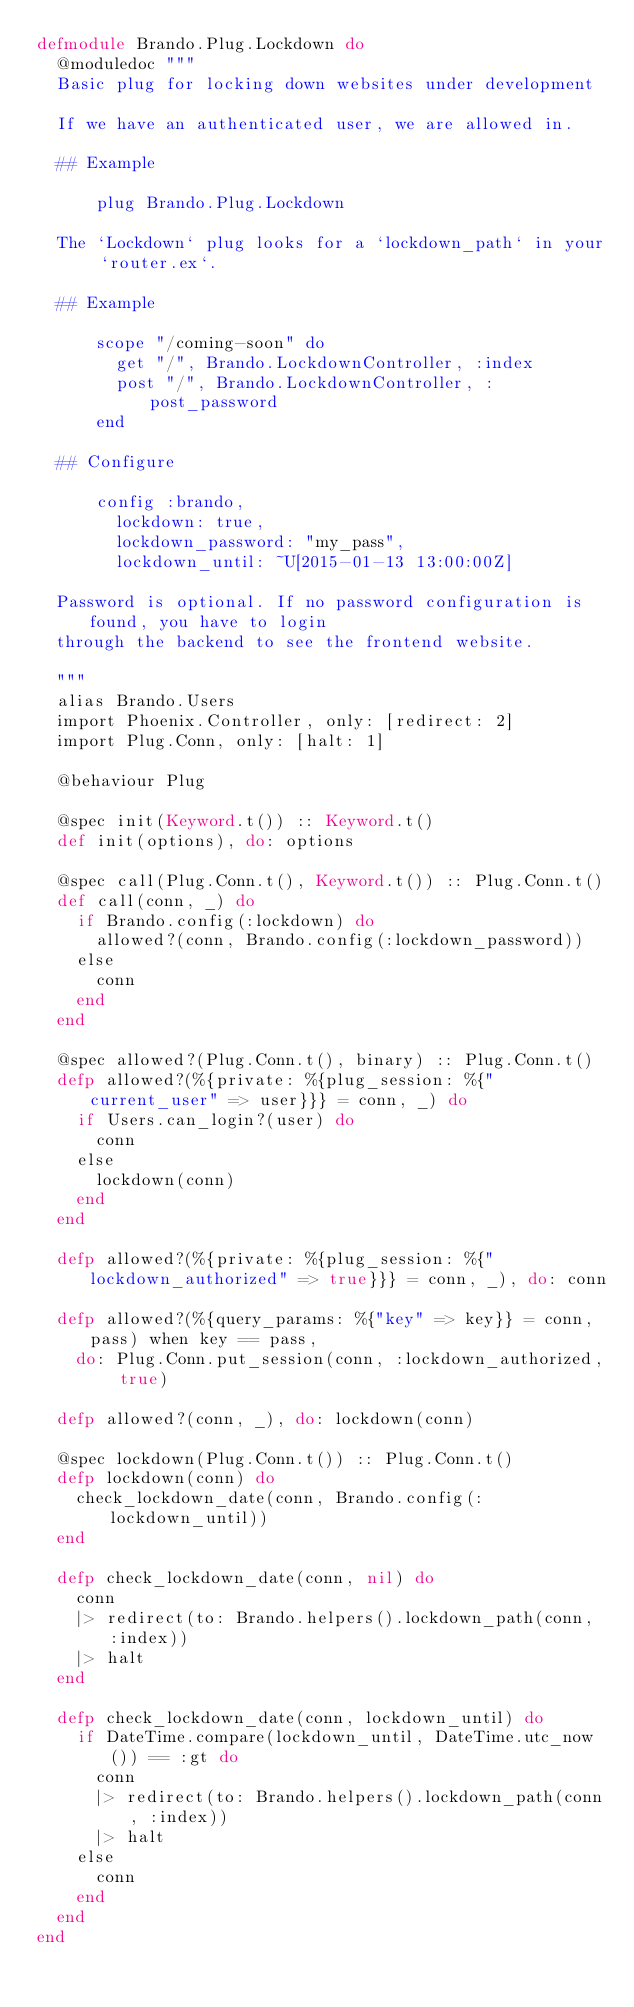<code> <loc_0><loc_0><loc_500><loc_500><_Elixir_>defmodule Brando.Plug.Lockdown do
  @moduledoc """
  Basic plug for locking down websites under development

  If we have an authenticated user, we are allowed in.

  ## Example

      plug Brando.Plug.Lockdown

  The `Lockdown` plug looks for a `lockdown_path` in your `router.ex`.

  ## Example

      scope "/coming-soon" do
        get "/", Brando.LockdownController, :index
        post "/", Brando.LockdownController, :post_password
      end

  ## Configure

      config :brando,
        lockdown: true,
        lockdown_password: "my_pass",
        lockdown_until: ~U[2015-01-13 13:00:00Z]

  Password is optional. If no password configuration is found, you have to login
  through the backend to see the frontend website.

  """
  alias Brando.Users
  import Phoenix.Controller, only: [redirect: 2]
  import Plug.Conn, only: [halt: 1]

  @behaviour Plug

  @spec init(Keyword.t()) :: Keyword.t()
  def init(options), do: options

  @spec call(Plug.Conn.t(), Keyword.t()) :: Plug.Conn.t()
  def call(conn, _) do
    if Brando.config(:lockdown) do
      allowed?(conn, Brando.config(:lockdown_password))
    else
      conn
    end
  end

  @spec allowed?(Plug.Conn.t(), binary) :: Plug.Conn.t()
  defp allowed?(%{private: %{plug_session: %{"current_user" => user}}} = conn, _) do
    if Users.can_login?(user) do
      conn
    else
      lockdown(conn)
    end
  end

  defp allowed?(%{private: %{plug_session: %{"lockdown_authorized" => true}}} = conn, _), do: conn

  defp allowed?(%{query_params: %{"key" => key}} = conn, pass) when key == pass,
    do: Plug.Conn.put_session(conn, :lockdown_authorized, true)

  defp allowed?(conn, _), do: lockdown(conn)

  @spec lockdown(Plug.Conn.t()) :: Plug.Conn.t()
  defp lockdown(conn) do
    check_lockdown_date(conn, Brando.config(:lockdown_until))
  end

  defp check_lockdown_date(conn, nil) do
    conn
    |> redirect(to: Brando.helpers().lockdown_path(conn, :index))
    |> halt
  end

  defp check_lockdown_date(conn, lockdown_until) do
    if DateTime.compare(lockdown_until, DateTime.utc_now()) == :gt do
      conn
      |> redirect(to: Brando.helpers().lockdown_path(conn, :index))
      |> halt
    else
      conn
    end
  end
end
</code> 